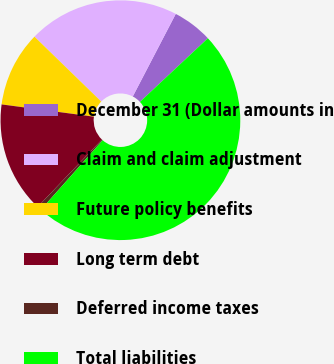<chart> <loc_0><loc_0><loc_500><loc_500><pie_chart><fcel>December 31 (Dollar amounts in<fcel>Claim and claim adjustment<fcel>Future policy benefits<fcel>Long term debt<fcel>Deferred income taxes<fcel>Total liabilities<nl><fcel>5.38%<fcel>20.37%<fcel>10.17%<fcel>14.97%<fcel>0.58%<fcel>48.54%<nl></chart> 